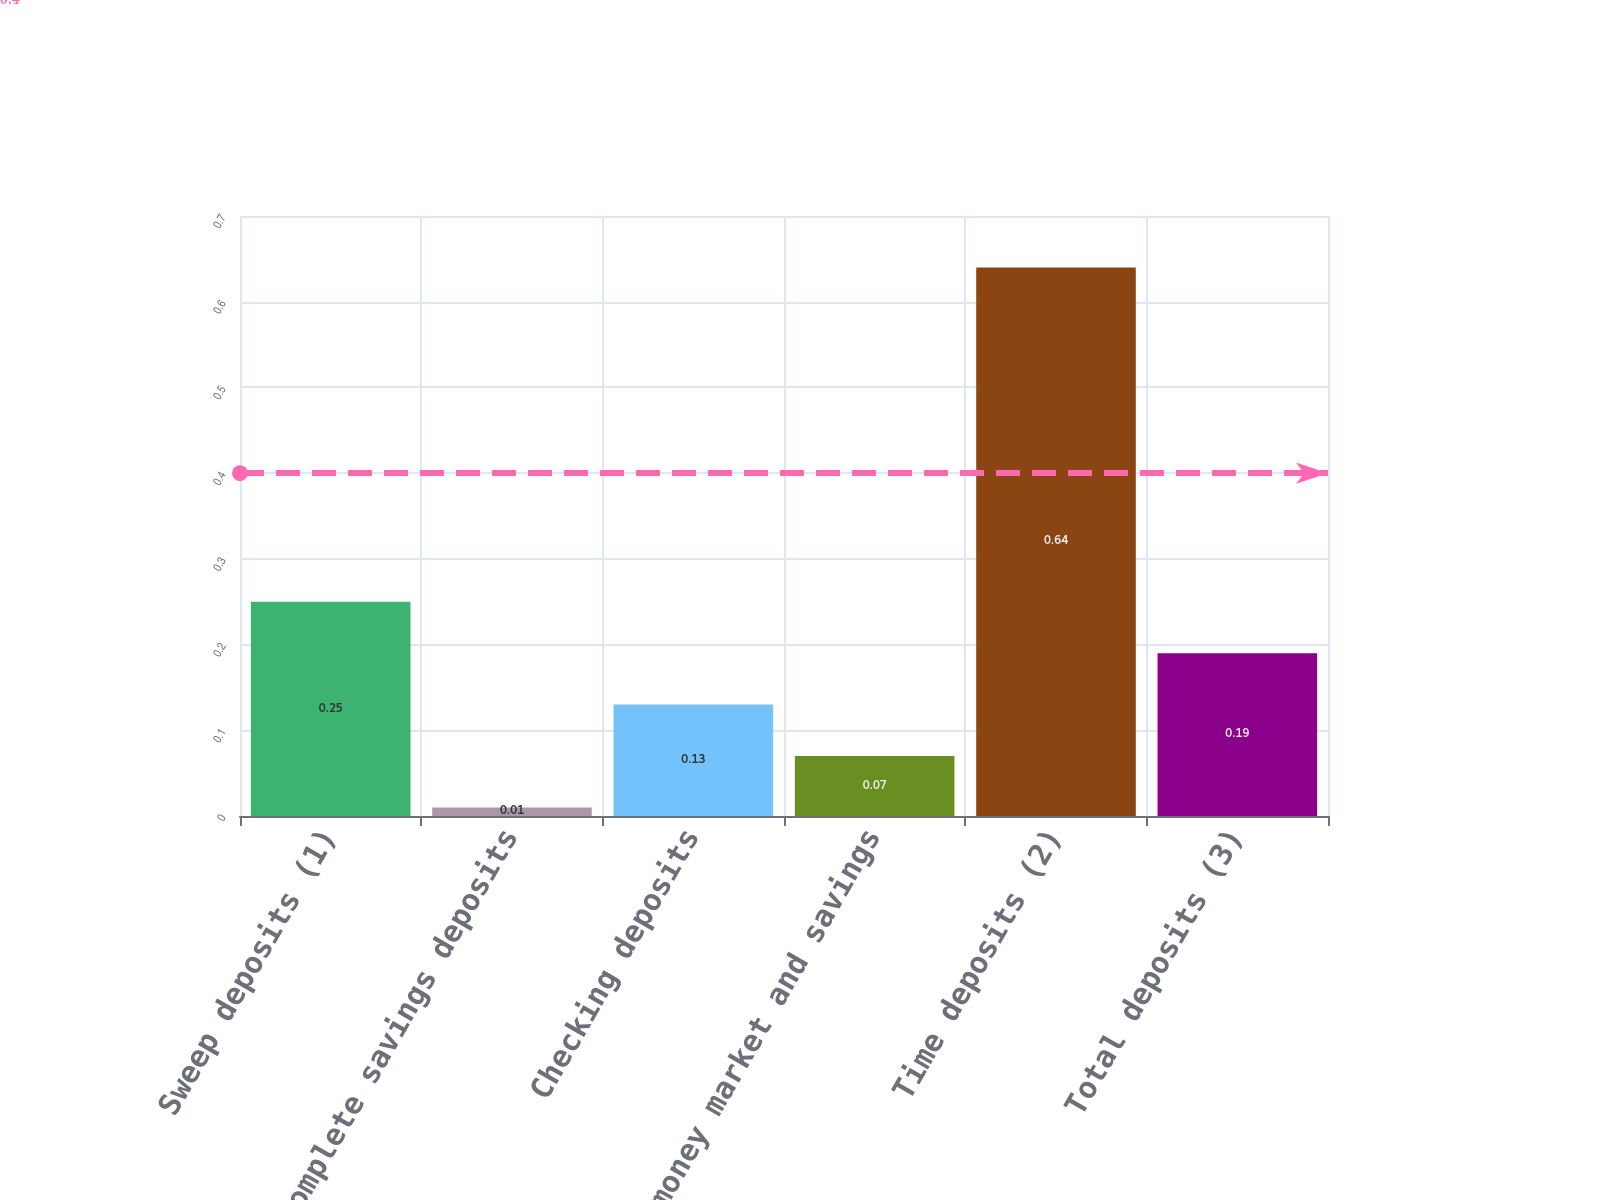<chart> <loc_0><loc_0><loc_500><loc_500><bar_chart><fcel>Sweep deposits (1)<fcel>Complete savings deposits<fcel>Checking deposits<fcel>Other money market and savings<fcel>Time deposits (2)<fcel>Total deposits (3)<nl><fcel>0.25<fcel>0.01<fcel>0.13<fcel>0.07<fcel>0.64<fcel>0.19<nl></chart> 